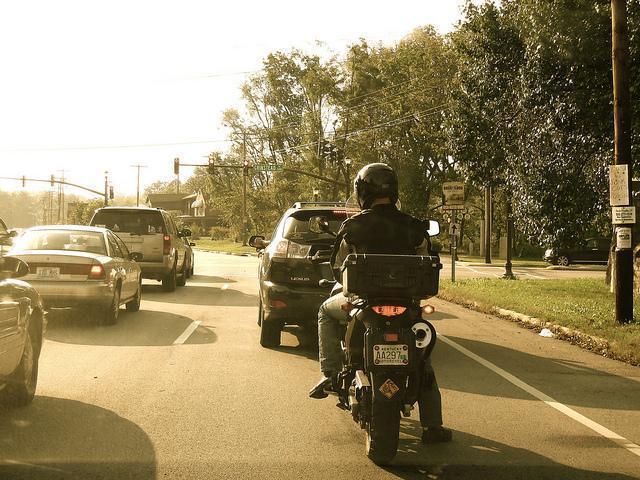For What reason does the person on the motorcycle have their right leg on the street?
Answer the question by selecting the correct answer among the 4 following choices.
Options: Balance, tapping angrily, kicking, stop bike. Balance. 